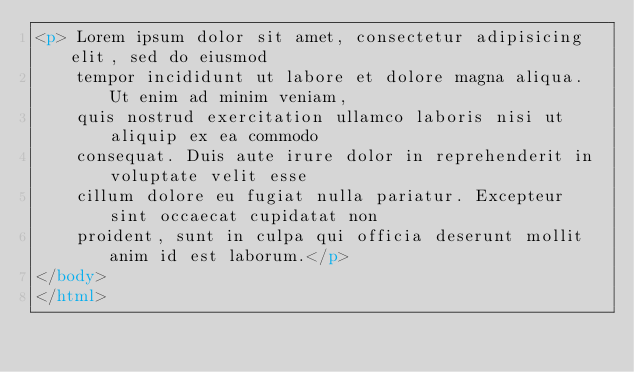Convert code to text. <code><loc_0><loc_0><loc_500><loc_500><_HTML_><p> Lorem ipsum dolor sit amet, consectetur adipisicing elit, sed do eiusmod
    tempor incididunt ut labore et dolore magna aliqua. Ut enim ad minim veniam,
    quis nostrud exercitation ullamco laboris nisi ut aliquip ex ea commodo
    consequat. Duis aute irure dolor in reprehenderit in voluptate velit esse
    cillum dolore eu fugiat nulla pariatur. Excepteur sint occaecat cupidatat non
    proident, sunt in culpa qui officia deserunt mollit anim id est laborum.</p>
</body>
</html></code> 